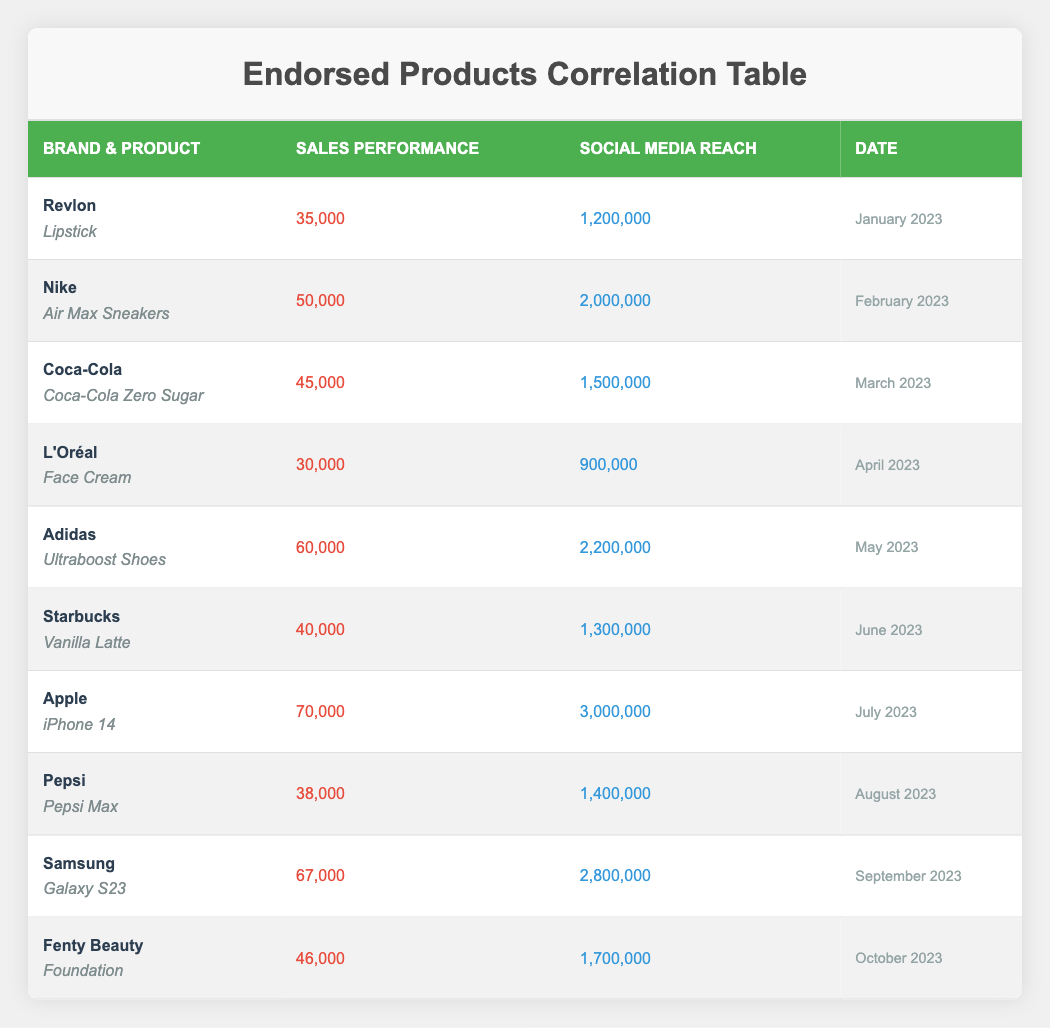What was the sales performance for the Adidas Ultraboost Shoes in May 2023? The table indicates that the sales performance for Adidas Ultraboost Shoes in May 2023 was 60,000.
Answer: 60,000 Which product had the highest social media reach and what was that reach? The product with the highest social media reach is the iPhone 14, with a reach of 3,000,000 in July 2023.
Answer: 3,000,000 What is the average sales performance for the products in the dataset? To find the average sales performance, sum all sales (35,000 + 50,000 + 45,000 + 30,000 + 60,000 + 40,000 + 70,000 + 38,000 + 67,000 + 46,000 = 511,000) and divide by the number of products (10). Thus, the average is 511,000 / 10 = 51,100.
Answer: 51,100 Did any product have a sales performance below 40,000? Yes, L'Oréal Face Cream had a sales performance of 30,000, which is below 40,000.
Answer: Yes Which brand had the lowest sales performance and what was the value? By examining the sales performance values, L'Oréal has the lowest sales performance at 30,000.
Answer: 30,000 How many products had a social media reach greater than 2,000,000? The products exceeding a social media reach of 2,000,000 are Nike's Air Max Sneakers, Adidas' Ultraboost Shoes, Apple's iPhone 14, and Samsung's Galaxy S23, totaling 4 products.
Answer: 4 Is the sales performance of the Coca-Cola Zero Sugar more than that of the Starbucks Vanilla Latte? Yes, Coca-Cola Zero Sugar had a sales performance of 45,000, which is more than Starbucks Vanilla Latte's performance of 40,000.
Answer: Yes What is the difference in sales performance between the highest and lowest performing products? The highest sales performance is 70,000 (iPhone 14) and the lowest is 30,000 (L'Oréal Face Cream). The difference is 70,000 - 30,000 = 40,000.
Answer: 40,000 Which month had the highest sales performance and what was the associated brand/product? The month with the highest sales performance is July 2023, associated with the brand Apple and the product iPhone 14, with sales of 70,000.
Answer: July 2023, Apple iPhone 14 